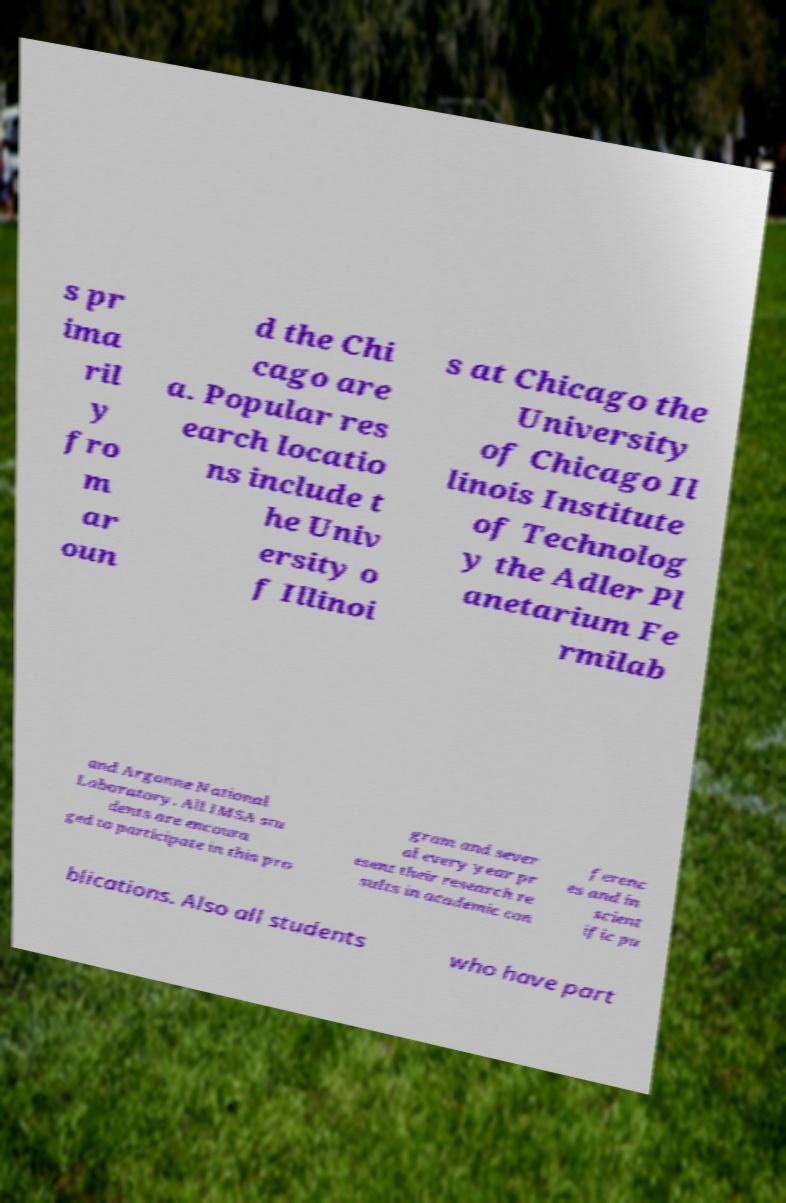Can you read and provide the text displayed in the image?This photo seems to have some interesting text. Can you extract and type it out for me? s pr ima ril y fro m ar oun d the Chi cago are a. Popular res earch locatio ns include t he Univ ersity o f Illinoi s at Chicago the University of Chicago Il linois Institute of Technolog y the Adler Pl anetarium Fe rmilab and Argonne National Laboratory. All IMSA stu dents are encoura ged to participate in this pro gram and sever al every year pr esent their research re sults in academic con ferenc es and in scient ific pu blications. Also all students who have part 